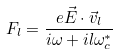<formula> <loc_0><loc_0><loc_500><loc_500>F _ { l } = \frac { e \vec { E } \cdot \vec { v } _ { l } } { i \omega + i l \omega _ { c } ^ { * } }</formula> 